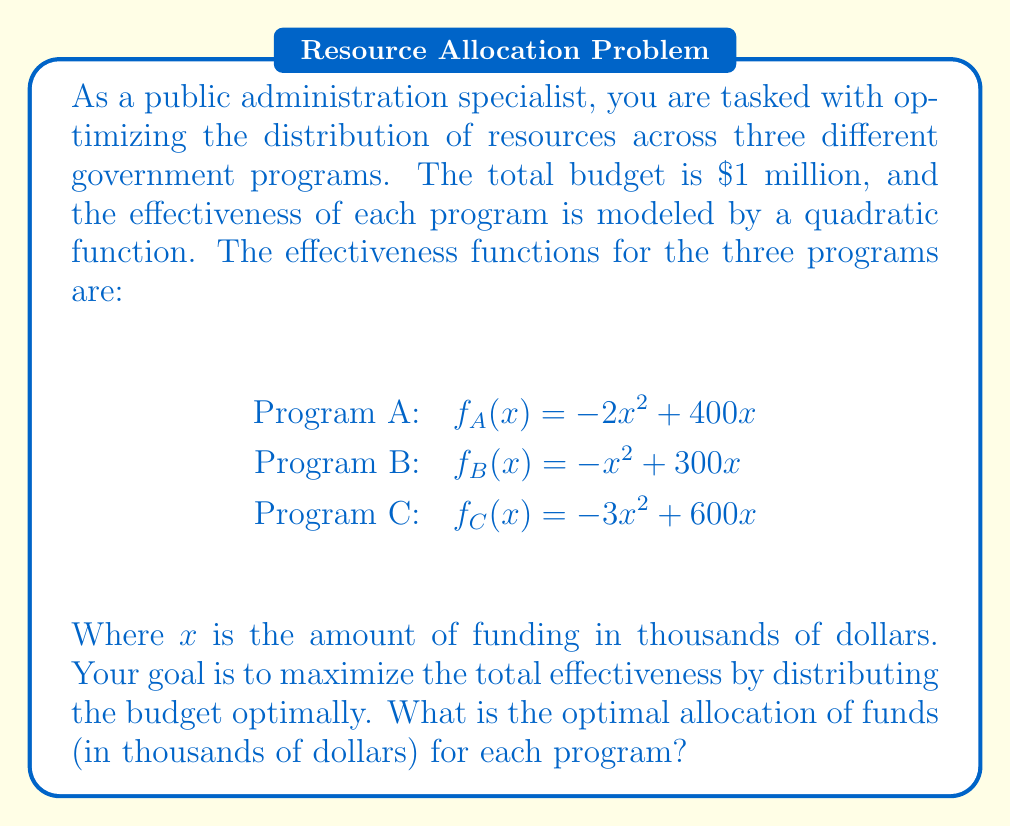Can you answer this question? To solve this optimization problem, we'll use the method of Lagrange multipliers:

1) Let $x$, $y$, and $z$ be the funding (in thousands) for programs A, B, and C respectively.

2) Our objective function is:
   $f(x,y,z) = (-2x^2 + 400x) + (-y^2 + 300y) + (-3z^2 + 600z)$

3) The constraint is:
   $g(x,y,z) = x + y + z - 1000 = 0$ (total budget constraint)

4) Form the Lagrangian:
   $L(x,y,z,\lambda) = f(x,y,z) - \lambda g(x,y,z)$

5) Take partial derivatives and set them to zero:
   $\frac{\partial L}{\partial x} = -4x + 400 - \lambda = 0$
   $\frac{\partial L}{\partial y} = -2y + 300 - \lambda = 0$
   $\frac{\partial L}{\partial z} = -6z + 600 - \lambda = 0$
   $\frac{\partial L}{\partial \lambda} = x + y + z - 1000 = 0$

6) From these equations:
   $x = 100 - \frac{\lambda}{4}$
   $y = 150 - \frac{\lambda}{2}$
   $z = 100 - \frac{\lambda}{6}$

7) Substitute into the constraint equation:
   $(100 - \frac{\lambda}{4}) + (150 - \frac{\lambda}{2}) + (100 - \frac{\lambda}{6}) = 1000$

8) Solve for $\lambda$:
   $350 - \frac{11\lambda}{12} = 1000$
   $\lambda = 600$

9) Substitute back to find $x$, $y$, and $z$:
   $x = 100 - \frac{600}{4} = 50$
   $y = 150 - \frac{600}{2} = 150$
   $z = 100 - \frac{600}{6} = 0$

Therefore, the optimal allocation is $50,000 for Program A, $150,000 for Program B, and $800,000 for Program C.
Answer: Program A: $50,000; Program B: $150,000; Program C: $800,000 